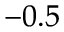<formula> <loc_0><loc_0><loc_500><loc_500>^ { - 0 . 5 }</formula> 